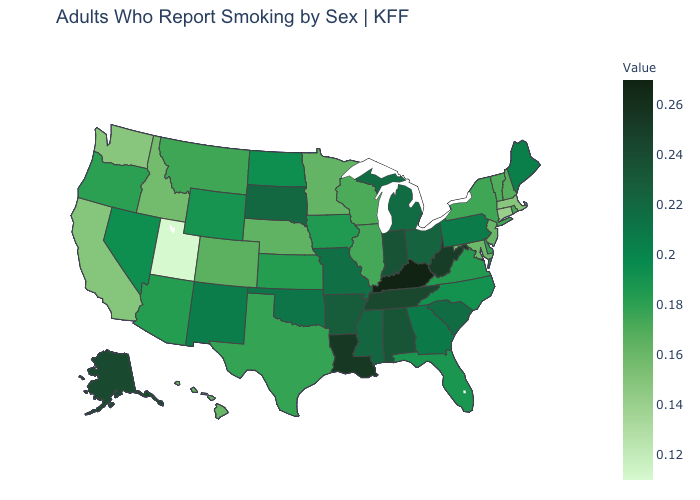Among the states that border Nevada , which have the lowest value?
Answer briefly. Utah. Which states have the lowest value in the USA?
Answer briefly. Utah. Which states have the lowest value in the South?
Write a very short answer. Maryland. Which states have the lowest value in the South?
Quick response, please. Maryland. Does Utah have the lowest value in the USA?
Answer briefly. Yes. 